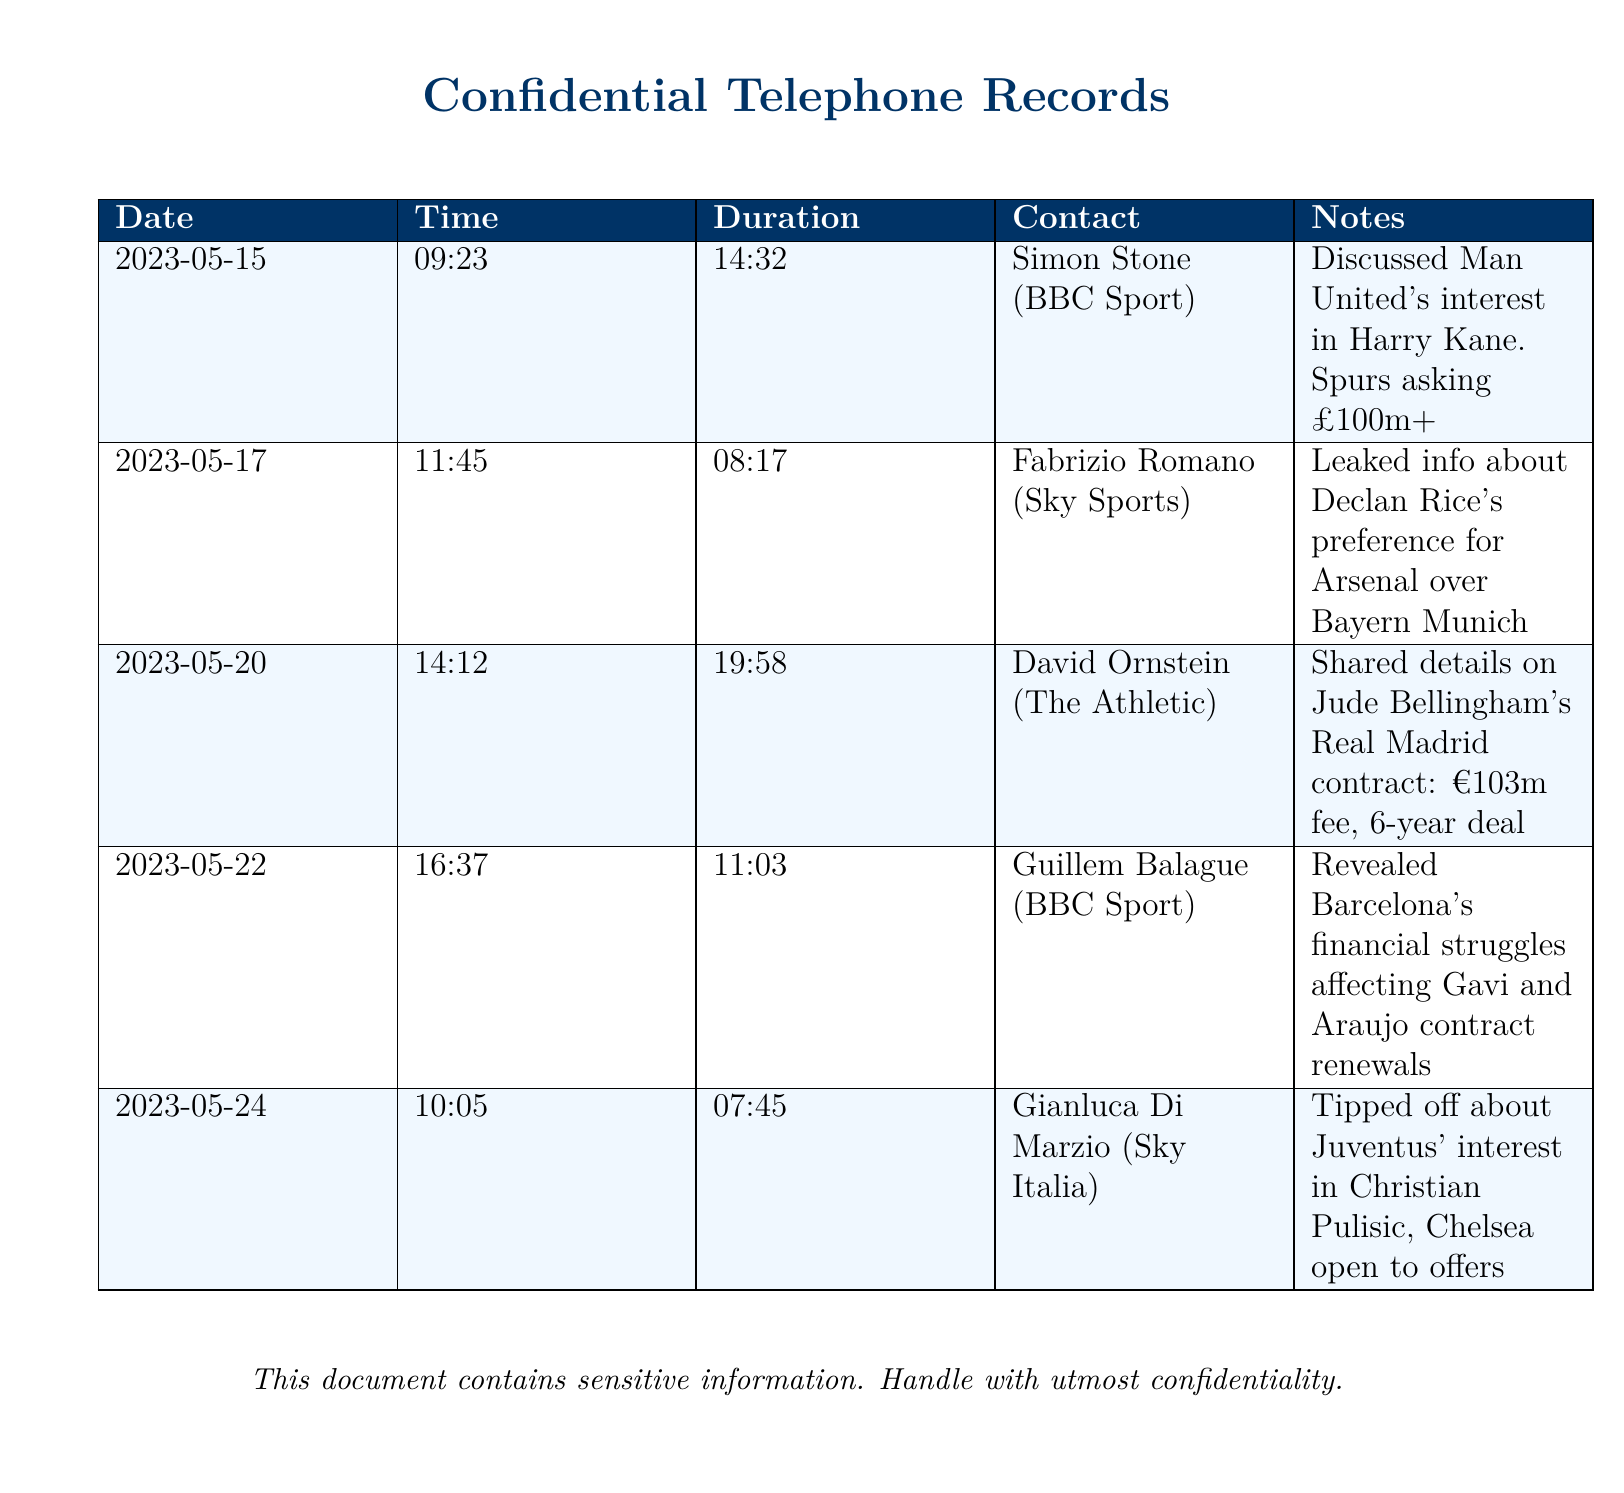what date did the call with Simon Stone occur? The call with Simon Stone took place on May 15, 2023.
Answer: May 15, 2023 how long was the call with Fabrizio Romano? The duration of the call with Fabrizio Romano was 8 minutes and 17 seconds.
Answer: 08:17 who is the contact for the leaked info about Declan Rice? The contact for the leaked info about Declan Rice is Fabrizio Romano.
Answer: Fabrizio Romano what was the fee for Jude Bellingham's contract with Real Madrid? The fee for Jude Bellingham's contract with Real Madrid is €103 million.
Answer: €103m which team is interested in Christian Pulisic according to Gianluca Di Marzio? According to Gianluca Di Marzio, Juventus is interested in Christian Pulisic.
Answer: Juventus how many calls were made regarding player transfers? There are a total of five calls made regarding player transfers.
Answer: 5 what time was the call with David Ornstein? The call with David Ornstein occurred at 2:12 PM.
Answer: 14:12 what was revealed about Barcelona's financial situation? It was revealed that Barcelona's financial struggles are affecting Gavi and Araujo contract renewals.
Answer: financial struggles affecting Gavi and Araujo contract renewals what is indicated about Arsenal's interest in Declan Rice? It is indicated that Declan Rice has a preference for Arsenal over Bayern Munich.
Answer: preference for Arsenal over Bayern Munich 